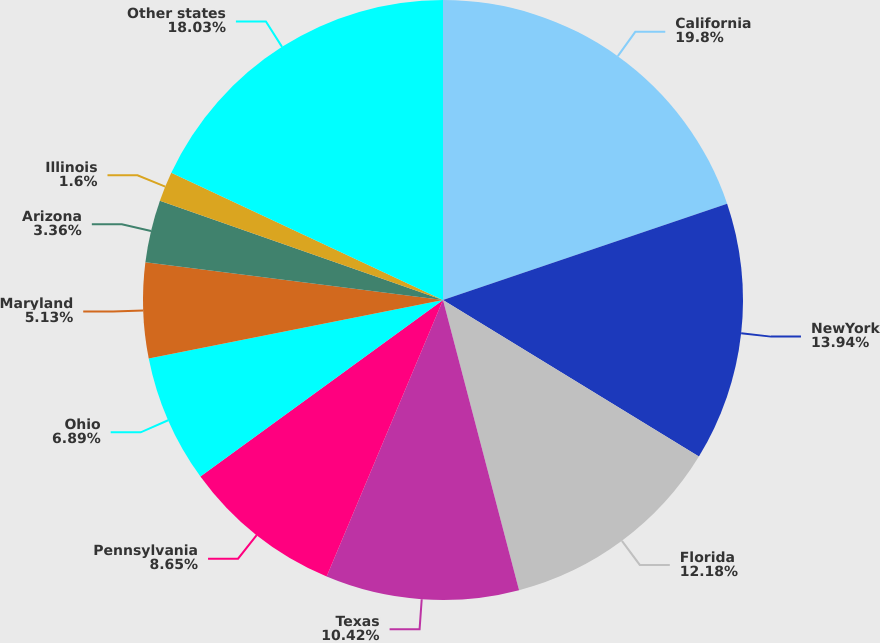Convert chart. <chart><loc_0><loc_0><loc_500><loc_500><pie_chart><fcel>California<fcel>NewYork<fcel>Florida<fcel>Texas<fcel>Pennsylvania<fcel>Ohio<fcel>Maryland<fcel>Arizona<fcel>Illinois<fcel>Other states<nl><fcel>19.8%<fcel>13.94%<fcel>12.18%<fcel>10.42%<fcel>8.65%<fcel>6.89%<fcel>5.13%<fcel>3.36%<fcel>1.6%<fcel>18.03%<nl></chart> 